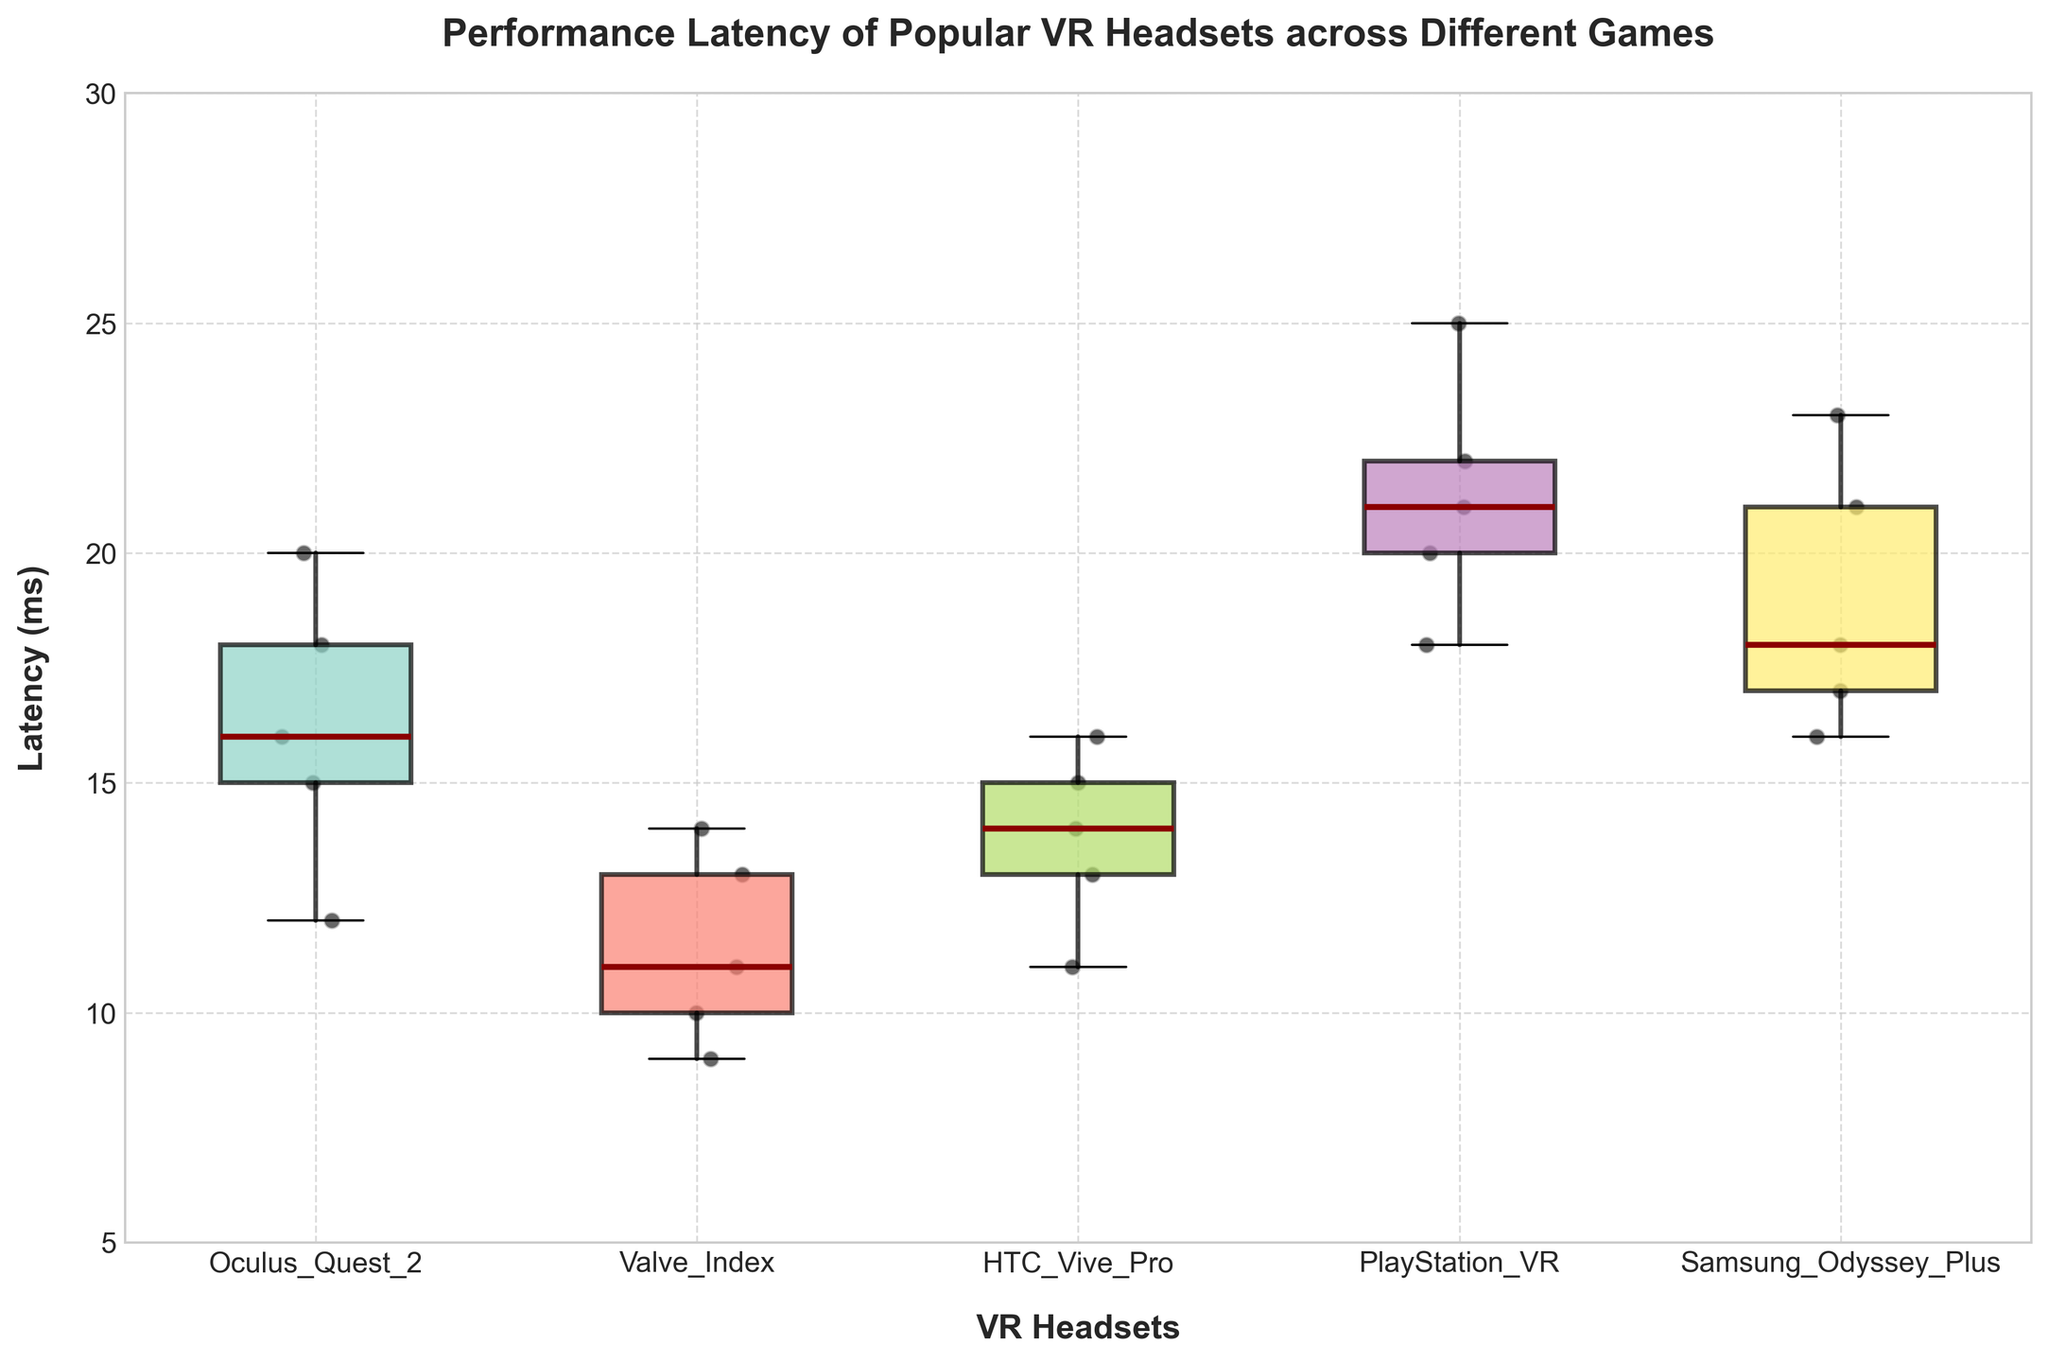What's the title of the figure? The title is located at the top center of the figure.
Answer: Performance Latency of Popular VR Headsets across Different Games What are the axes labeled as? The x-axis label can be found toward the bottom, and the y-axis label can be found towards the left side of the figure.
Answer: The x-axis is labeled 'VR Headsets', and the y-axis is labeled 'Latency (ms)' Which VR headset has the highest median latency? In a box plot, the median latency is shown by the line within each box. Identify the box plot with the highest median line.
Answer: PlayStation VR What is the range of latency values for the Valve Index? The range of latency values can be observed by looking at the bottom and top whiskers of the box plot for the Valve Index.
Answer: 9 ms to 14 ms How does the median latency of Oculus Quest 2 compare to HTC Vive Pro? Compare the position of the median lines (inside the boxes) for the two headsets in their respective box plots.
Answer: The median latency of Oculus Quest 2 is higher than HTC Vive Pro Which VR headset has the smallest interquartile range (IQR)? The IQR is represented by the height of the box, which shows the range between the first and third quartiles. Identify the headset with the smallest box.
Answer: Valve Index How many data points are shown for each VR headset? Count the individual black dots scattered around the respective box plots for each VR headset.
Answer: 5 data points per VR headset What is the maximum latency observed for PlayStation VR? The maximum latency is indicated by the top whisker of the box plot for PlayStation VR.
Answer: 25 ms Compare the spread of latencies between Valve Index and Samsung Odyssey Plus. The spread of latencies is shown by the length of the whiskers and the size of the box. Compare these elements between the two headsets.
Answer: Valve Index has a smaller spread of latencies compared to Samsung Odyssey Plus What is the median latency for Beat Saber on all headsets combined? To find the combined median latency, list all latency values for Beat Saber across all headsets and find the median of this combined list.
Answer: 15 ms 